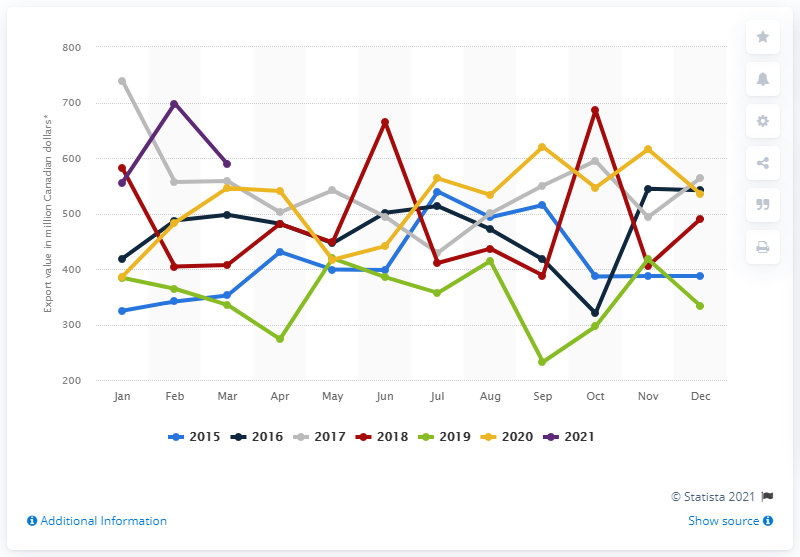Give some essential details in this illustration. Exports of canola from Canada in March 2021 totaled CAD 594.8 million. 